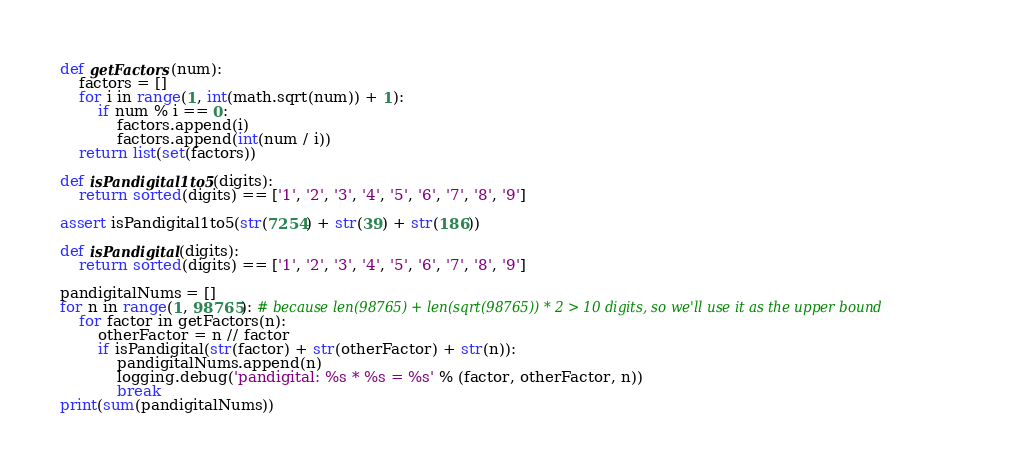Convert code to text. <code><loc_0><loc_0><loc_500><loc_500><_Python_>

def getFactors(num):
    factors = []
    for i in range(1, int(math.sqrt(num)) + 1):
        if num % i == 0:
            factors.append(i)
            factors.append(int(num / i))
    return list(set(factors))

def isPandigital1to5(digits):
    return sorted(digits) == ['1', '2', '3', '4', '5', '6', '7', '8', '9']

assert isPandigital1to5(str(7254) + str(39) + str(186))

def isPandigital(digits):
    return sorted(digits) == ['1', '2', '3', '4', '5', '6', '7', '8', '9']

pandigitalNums = []
for n in range(1, 98765): # because len(98765) + len(sqrt(98765)) * 2 > 10 digits, so we'll use it as the upper bound
    for factor in getFactors(n):
        otherFactor = n // factor
        if isPandigital(str(factor) + str(otherFactor) + str(n)):
            pandigitalNums.append(n)
            logging.debug('pandigital: %s * %s = %s' % (factor, otherFactor, n))
            break
print(sum(pandigitalNums))</code> 